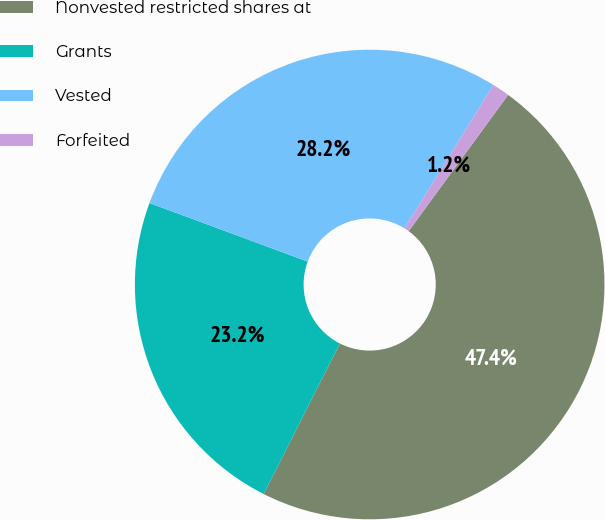<chart> <loc_0><loc_0><loc_500><loc_500><pie_chart><fcel>Nonvested restricted shares at<fcel>Grants<fcel>Vested<fcel>Forfeited<nl><fcel>47.42%<fcel>23.19%<fcel>28.19%<fcel>1.21%<nl></chart> 